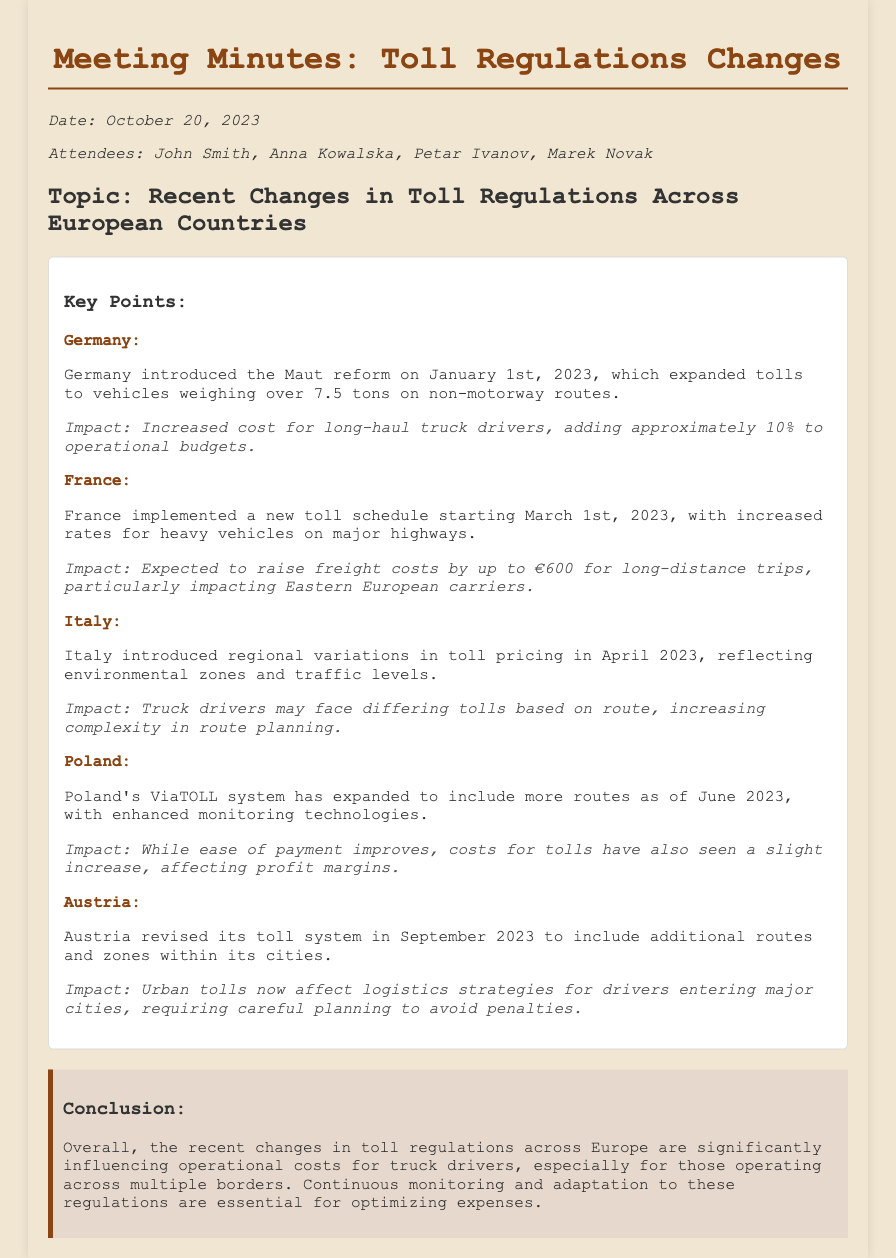what was the date of the meeting? The date is specified in the document as October 20, 2023.
Answer: October 20, 2023 who introduced the Maut reform? The document states that Germany introduced the Maut reform.
Answer: Germany when did Poland expand its ViaTOLL system? The expansion date for Poland's ViaTOLL system is mentioned as June 2023.
Answer: June 2023 what is the impact of France's new toll schedule? The document indicates that the impact is expected to raise freight costs by up to €600.
Answer: up to €600 how did Italy's toll pricing change? The document explains that Italy introduced regional variations in toll pricing.
Answer: regional variations what is a key requirement for drivers due to Austria's toll updates? The impact noted is that careful planning is required to avoid penalties in urban tolls.
Answer: careful planning which country implemented a toll reform on January 1, 2023? The document specifies that Germany implemented the toll reform on this date.
Answer: Germany what is the main conclusion regarding toll regulation changes? The conclusion emphasizes the significant influencing of operational costs for truck drivers.
Answer: influencing operational costs 